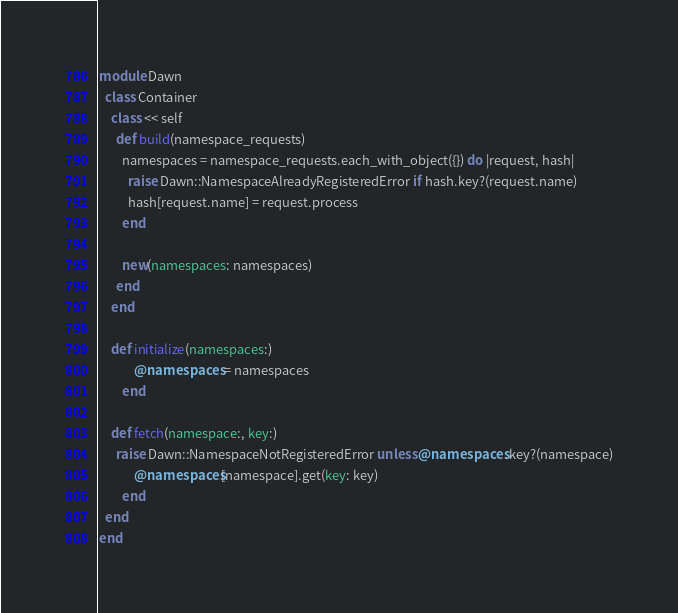Convert code to text. <code><loc_0><loc_0><loc_500><loc_500><_Ruby_>module Dawn
  class Container
    class << self
      def build(namespace_requests)
        namespaces = namespace_requests.each_with_object({}) do |request, hash|
          raise Dawn::NamespaceAlreadyRegisteredError if hash.key?(request.name)
          hash[request.name] = request.process
        end

        new(namespaces: namespaces)
      end
    end

    def initialize(namespaces:)
			@namespaces = namespaces
		end

    def fetch(namespace:, key:)
      raise Dawn::NamespaceNotRegisteredError unless @namespaces.key?(namespace)
			@namespaces[namespace].get(key: key)
		end
  end
end</code> 